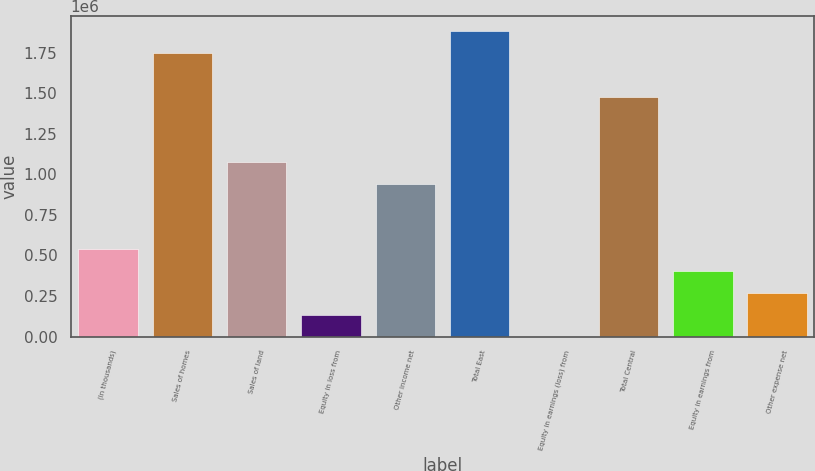Convert chart. <chart><loc_0><loc_0><loc_500><loc_500><bar_chart><fcel>(In thousands)<fcel>Sales of homes<fcel>Sales of land<fcel>Equity in loss from<fcel>Other income net<fcel>Total East<fcel>Equity in earnings (loss) from<fcel>Total Central<fcel>Equity in earnings from<fcel>Other expense net<nl><fcel>538017<fcel>1.74839e+06<fcel>1.07596e+06<fcel>134560<fcel>941475<fcel>1.88288e+06<fcel>74<fcel>1.47942e+06<fcel>403531<fcel>269046<nl></chart> 